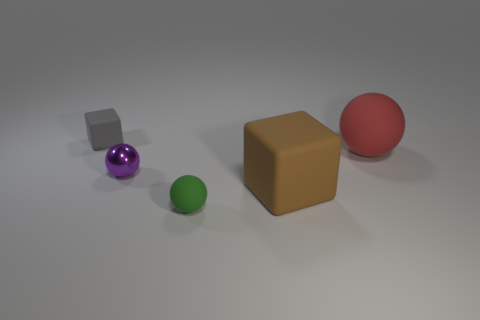Add 2 tiny shiny things. How many objects exist? 7 Subtract all blocks. How many objects are left? 3 Add 3 rubber blocks. How many rubber blocks are left? 5 Add 4 tiny gray rubber objects. How many tiny gray rubber objects exist? 5 Subtract 0 purple cylinders. How many objects are left? 5 Subtract all large brown rubber things. Subtract all big balls. How many objects are left? 3 